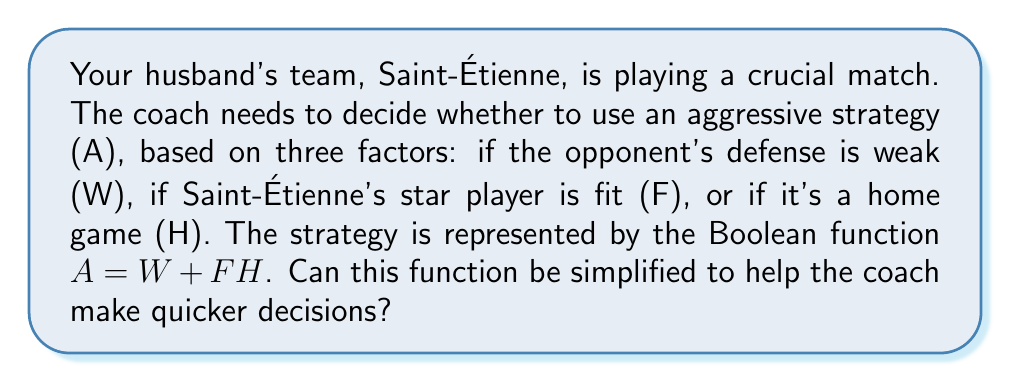Show me your answer to this math problem. Let's simplify the Boolean function $A = W + FH$ step-by-step:

1) First, we should check if we can apply any Boolean algebra laws to simplify this expression.

2) The expression is already in its sum-of-products (SOP) form, which is generally considered simple. However, we can check if we can apply the distributive law.

3) To do this, we need to find a common term to factor out. In this case, there isn't one, so we can't simplify further using distribution.

4) We can also check if we can apply absorption law, but since W is not multiplied by any term, this law doesn't apply either.

5) Therefore, the expression $A = W + FH$ is already in its simplest form.

6) This means that the coach should use the aggressive strategy (A) if:
   - The opponent's defense is weak (W), OR
   - It's a home game (H) AND Saint-Étienne's star player is fit (F)

This simplified form allows for quick decision-making based on these clear conditions.
Answer: $A = W + FH$ 